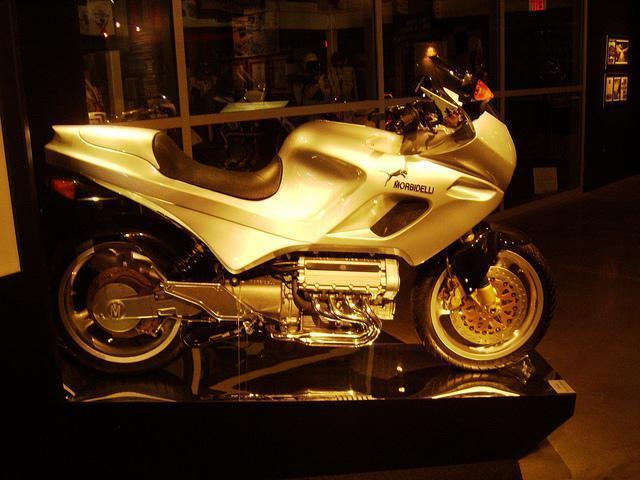How many bikes are there?
Give a very brief answer. 1. How many people carriages do you see?
Give a very brief answer. 0. 